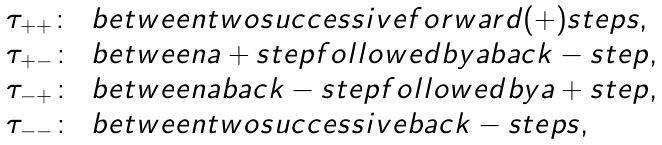<formula> <loc_0><loc_0><loc_500><loc_500>\begin{array} { l l } \, \tau _ { + + } \colon & b e t w e e n t w o s u c c e s s i v e f o r w a r d ( + ) s t e p s , \\ \, \tau _ { + - } \colon & b e t w e e n a + s t e p f o l l o w e d b y a b a c k - s t e p , \\ \, \tau _ { - + } \colon & b e t w e e n a b a c k - s t e p f o l l o w e d b y a + s t e p , \\ \, \tau _ { - - } \colon & b e t w e e n t w o s u c c e s s i v e b a c k - s t e p s , \end{array}</formula> 